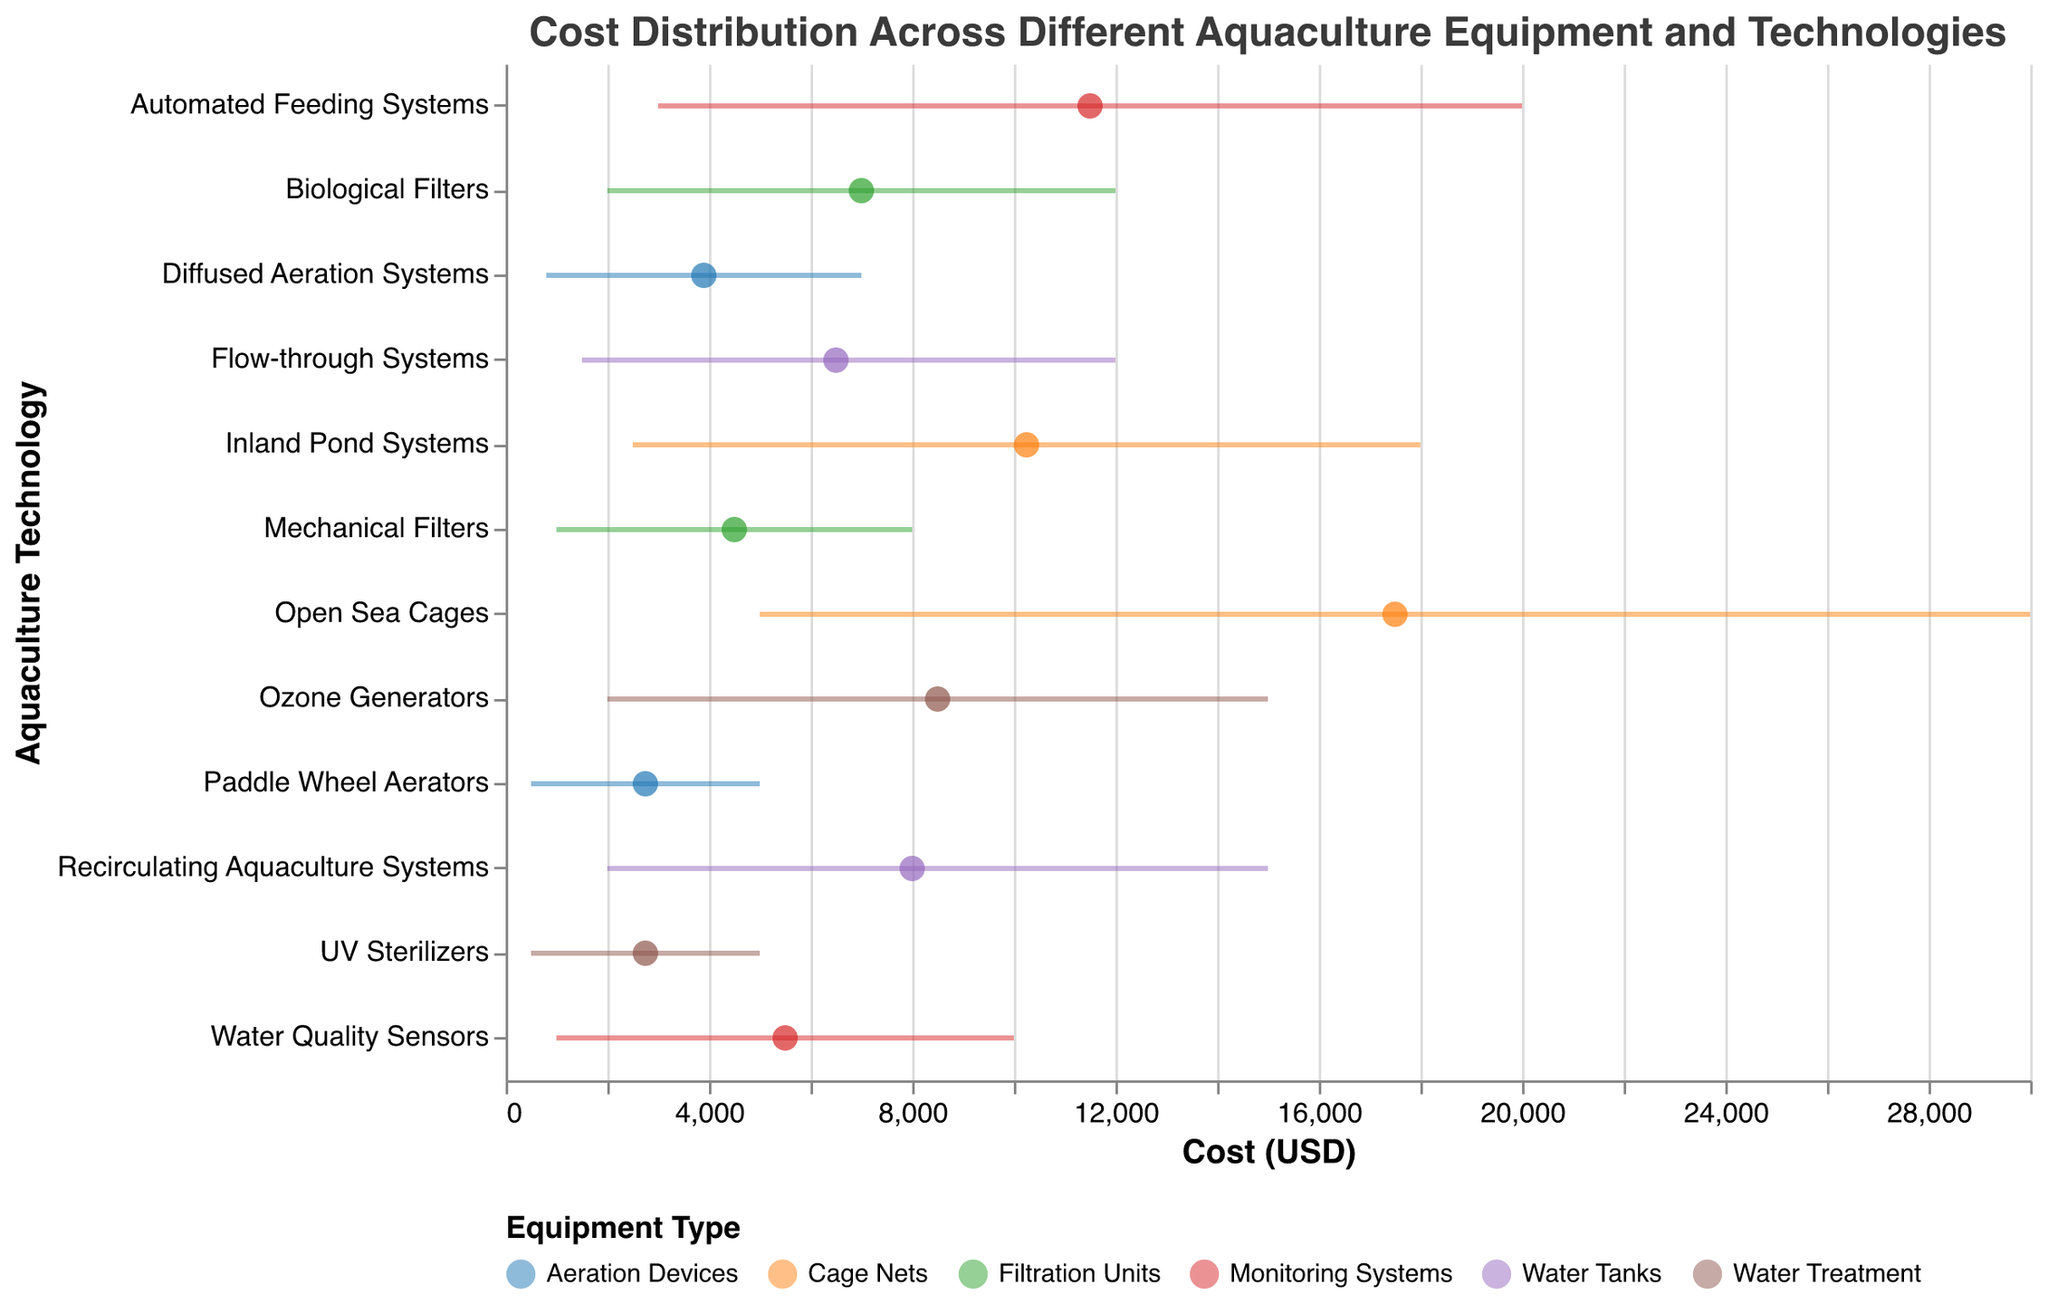what's the title of the figure? The title is displayed at the top of the figure and indicates what the plot is about. Here, it says "Cost Distribution Across Different Aquaculture Equipment and Technologies".
Answer: Cost Distribution Across Different Aquaculture Equipment and Technologies how many types of equipment are shown in the figure? To determine the number of equipment types, look at the legend at the bottom of the figure. Each color corresponds to a different type of equipment.
Answer: Six which technology has the highest average cost? To find this, look at the x-axis values for average costs and identify the technology with the highest value. "Open Sea Cages" has the highest average cost marked on the x-axis.
Answer: Open Sea Cages what is the average cost of Water Quality Sensors? First, locate "Water Quality Sensors" on the y-axis. Then, follow the corresponding dot on the x-axis which shows the average cost.
Answer: 5500 which technologies have an average cost greater than 10000 USD? Scan the x-axis for costs greater than 10000 and check which technologies' corresponding points fall in this range. Both "Open Sea Cages" and "Automated Feeding Systems" have average costs greater than 10000 USD.
Answer: Open Sea Cages, Automated Feeding Systems what's the range of costs for Biological Filters? Find "Biological Filters" on the y-axis and then look at the horizontal line (rule) extending from MinCost to MaxCost.
Answer: 2000-12000 which equipment type has the widest range of costs? To determine this, calculate the difference between MinCost and MaxCost for each equipment type and compare them. "Cage Nets" (specifically "Open Sea Cages") has the widest range from 5000 to 30000.
Answer: Cage Nets how does the average cost of Recirculating Aquaculture Systems compare to Flow-through Systems? Locate both technologies on the y-axis and compare their average costs on the x-axis. "Recirculating Aquaculture Systems" has an average cost of 8000, which is higher than the 6500 of "Flow-through Systems".
Answer: Recirculating Aquaculture Systems is higher which technology within Cage Nets has the lower minimum cost, and what is it? Look at the MinCost values for technologies under "Cage Nets". "Inland Pond Systems" has a lower minimum cost compared to "Open Sea Cages".
Answer: Inland Pond Systems, 2500 